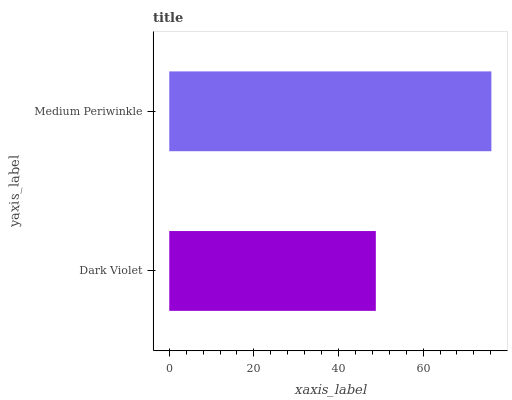Is Dark Violet the minimum?
Answer yes or no. Yes. Is Medium Periwinkle the maximum?
Answer yes or no. Yes. Is Medium Periwinkle the minimum?
Answer yes or no. No. Is Medium Periwinkle greater than Dark Violet?
Answer yes or no. Yes. Is Dark Violet less than Medium Periwinkle?
Answer yes or no. Yes. Is Dark Violet greater than Medium Periwinkle?
Answer yes or no. No. Is Medium Periwinkle less than Dark Violet?
Answer yes or no. No. Is Medium Periwinkle the high median?
Answer yes or no. Yes. Is Dark Violet the low median?
Answer yes or no. Yes. Is Dark Violet the high median?
Answer yes or no. No. Is Medium Periwinkle the low median?
Answer yes or no. No. 